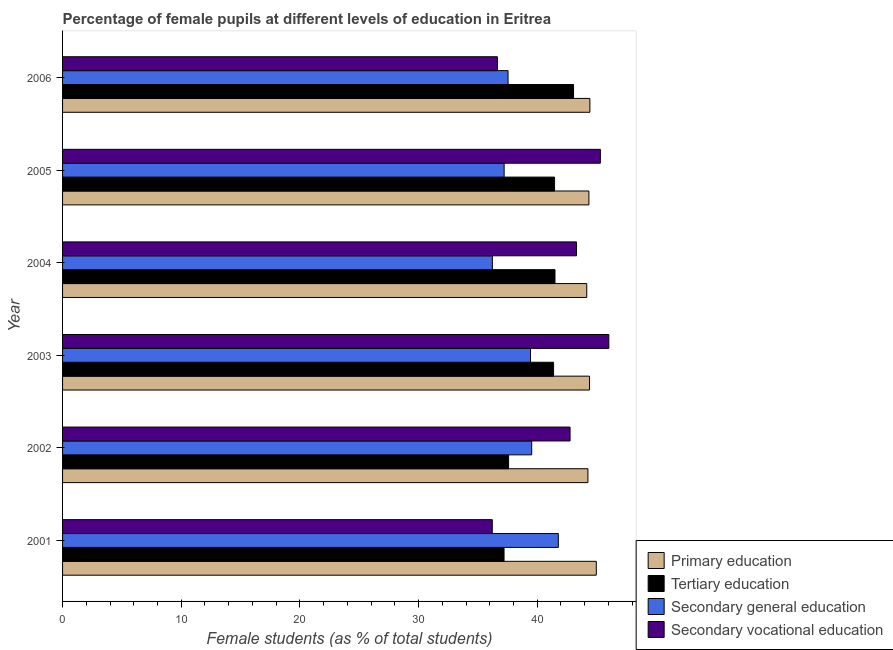How many different coloured bars are there?
Keep it short and to the point. 4. How many groups of bars are there?
Offer a very short reply. 6. Are the number of bars per tick equal to the number of legend labels?
Offer a very short reply. Yes. How many bars are there on the 2nd tick from the top?
Provide a succinct answer. 4. In how many cases, is the number of bars for a given year not equal to the number of legend labels?
Your response must be concise. 0. What is the percentage of female students in tertiary education in 2004?
Your answer should be very brief. 41.5. Across all years, what is the maximum percentage of female students in secondary vocational education?
Keep it short and to the point. 46.03. Across all years, what is the minimum percentage of female students in primary education?
Provide a short and direct response. 44.17. In which year was the percentage of female students in tertiary education maximum?
Give a very brief answer. 2006. In which year was the percentage of female students in primary education minimum?
Provide a succinct answer. 2004. What is the total percentage of female students in secondary vocational education in the graph?
Your answer should be compact. 250.29. What is the difference between the percentage of female students in primary education in 2003 and that in 2005?
Provide a succinct answer. 0.05. What is the difference between the percentage of female students in primary education in 2003 and the percentage of female students in secondary vocational education in 2005?
Provide a succinct answer. -0.91. What is the average percentage of female students in secondary education per year?
Your answer should be compact. 38.62. In the year 2005, what is the difference between the percentage of female students in secondary vocational education and percentage of female students in secondary education?
Offer a very short reply. 8.11. In how many years, is the percentage of female students in tertiary education greater than 34 %?
Keep it short and to the point. 6. What is the ratio of the percentage of female students in secondary education in 2001 to that in 2006?
Your answer should be compact. 1.11. What is the difference between the highest and the second highest percentage of female students in primary education?
Ensure brevity in your answer.  0.54. What is the difference between the highest and the lowest percentage of female students in tertiary education?
Keep it short and to the point. 5.86. In how many years, is the percentage of female students in primary education greater than the average percentage of female students in primary education taken over all years?
Provide a short and direct response. 2. Is it the case that in every year, the sum of the percentage of female students in secondary vocational education and percentage of female students in tertiary education is greater than the sum of percentage of female students in secondary education and percentage of female students in primary education?
Keep it short and to the point. No. What does the 2nd bar from the top in 2006 represents?
Keep it short and to the point. Secondary general education. What does the 3rd bar from the bottom in 2002 represents?
Give a very brief answer. Secondary general education. Is it the case that in every year, the sum of the percentage of female students in primary education and percentage of female students in tertiary education is greater than the percentage of female students in secondary education?
Make the answer very short. Yes. How many bars are there?
Make the answer very short. 24. Are all the bars in the graph horizontal?
Keep it short and to the point. Yes. Does the graph contain grids?
Offer a very short reply. No. Where does the legend appear in the graph?
Your answer should be very brief. Bottom right. How many legend labels are there?
Keep it short and to the point. 4. What is the title of the graph?
Provide a succinct answer. Percentage of female pupils at different levels of education in Eritrea. What is the label or title of the X-axis?
Your answer should be compact. Female students (as % of total students). What is the Female students (as % of total students) in Primary education in 2001?
Your answer should be compact. 44.98. What is the Female students (as % of total students) in Tertiary education in 2001?
Provide a succinct answer. 37.2. What is the Female students (as % of total students) of Secondary general education in 2001?
Offer a terse response. 41.78. What is the Female students (as % of total students) of Secondary vocational education in 2001?
Give a very brief answer. 36.21. What is the Female students (as % of total students) of Primary education in 2002?
Your response must be concise. 44.27. What is the Female students (as % of total students) in Tertiary education in 2002?
Offer a very short reply. 37.59. What is the Female students (as % of total students) in Secondary general education in 2002?
Provide a short and direct response. 39.53. What is the Female students (as % of total students) in Secondary vocational education in 2002?
Offer a very short reply. 42.77. What is the Female students (as % of total students) of Primary education in 2003?
Give a very brief answer. 44.41. What is the Female students (as % of total students) in Tertiary education in 2003?
Provide a succinct answer. 41.38. What is the Female students (as % of total students) in Secondary general education in 2003?
Give a very brief answer. 39.44. What is the Female students (as % of total students) of Secondary vocational education in 2003?
Offer a terse response. 46.03. What is the Female students (as % of total students) in Primary education in 2004?
Your answer should be very brief. 44.17. What is the Female students (as % of total students) in Tertiary education in 2004?
Your response must be concise. 41.5. What is the Female students (as % of total students) in Secondary general education in 2004?
Give a very brief answer. 36.22. What is the Female students (as % of total students) in Secondary vocational education in 2004?
Your response must be concise. 43.31. What is the Female students (as % of total students) of Primary education in 2005?
Provide a succinct answer. 44.36. What is the Female students (as % of total students) in Tertiary education in 2005?
Offer a very short reply. 41.46. What is the Female students (as % of total students) of Secondary general education in 2005?
Your response must be concise. 37.21. What is the Female students (as % of total students) in Secondary vocational education in 2005?
Provide a short and direct response. 45.32. What is the Female students (as % of total students) in Primary education in 2006?
Provide a short and direct response. 44.44. What is the Female students (as % of total students) of Tertiary education in 2006?
Give a very brief answer. 43.06. What is the Female students (as % of total students) of Secondary general education in 2006?
Give a very brief answer. 37.54. What is the Female students (as % of total students) in Secondary vocational education in 2006?
Your response must be concise. 36.65. Across all years, what is the maximum Female students (as % of total students) in Primary education?
Keep it short and to the point. 44.98. Across all years, what is the maximum Female students (as % of total students) of Tertiary education?
Offer a terse response. 43.06. Across all years, what is the maximum Female students (as % of total students) in Secondary general education?
Ensure brevity in your answer.  41.78. Across all years, what is the maximum Female students (as % of total students) of Secondary vocational education?
Make the answer very short. 46.03. Across all years, what is the minimum Female students (as % of total students) in Primary education?
Your response must be concise. 44.17. Across all years, what is the minimum Female students (as % of total students) in Tertiary education?
Provide a short and direct response. 37.2. Across all years, what is the minimum Female students (as % of total students) of Secondary general education?
Offer a terse response. 36.22. Across all years, what is the minimum Female students (as % of total students) in Secondary vocational education?
Your response must be concise. 36.21. What is the total Female students (as % of total students) of Primary education in the graph?
Ensure brevity in your answer.  266.63. What is the total Female students (as % of total students) in Tertiary education in the graph?
Give a very brief answer. 242.19. What is the total Female students (as % of total students) in Secondary general education in the graph?
Give a very brief answer. 231.72. What is the total Female students (as % of total students) of Secondary vocational education in the graph?
Provide a short and direct response. 250.29. What is the difference between the Female students (as % of total students) of Primary education in 2001 and that in 2002?
Your response must be concise. 0.71. What is the difference between the Female students (as % of total students) of Tertiary education in 2001 and that in 2002?
Provide a short and direct response. -0.38. What is the difference between the Female students (as % of total students) of Secondary general education in 2001 and that in 2002?
Keep it short and to the point. 2.25. What is the difference between the Female students (as % of total students) of Secondary vocational education in 2001 and that in 2002?
Keep it short and to the point. -6.55. What is the difference between the Female students (as % of total students) of Primary education in 2001 and that in 2003?
Keep it short and to the point. 0.57. What is the difference between the Female students (as % of total students) of Tertiary education in 2001 and that in 2003?
Ensure brevity in your answer.  -4.17. What is the difference between the Female students (as % of total students) of Secondary general education in 2001 and that in 2003?
Give a very brief answer. 2.34. What is the difference between the Female students (as % of total students) in Secondary vocational education in 2001 and that in 2003?
Keep it short and to the point. -9.82. What is the difference between the Female students (as % of total students) of Primary education in 2001 and that in 2004?
Make the answer very short. 0.8. What is the difference between the Female students (as % of total students) of Tertiary education in 2001 and that in 2004?
Offer a very short reply. -4.29. What is the difference between the Female students (as % of total students) of Secondary general education in 2001 and that in 2004?
Provide a succinct answer. 5.56. What is the difference between the Female students (as % of total students) in Secondary vocational education in 2001 and that in 2004?
Provide a succinct answer. -7.1. What is the difference between the Female students (as % of total students) of Primary education in 2001 and that in 2005?
Make the answer very short. 0.62. What is the difference between the Female students (as % of total students) in Tertiary education in 2001 and that in 2005?
Give a very brief answer. -4.26. What is the difference between the Female students (as % of total students) of Secondary general education in 2001 and that in 2005?
Keep it short and to the point. 4.57. What is the difference between the Female students (as % of total students) of Secondary vocational education in 2001 and that in 2005?
Provide a short and direct response. -9.11. What is the difference between the Female students (as % of total students) in Primary education in 2001 and that in 2006?
Your response must be concise. 0.54. What is the difference between the Female students (as % of total students) of Tertiary education in 2001 and that in 2006?
Provide a short and direct response. -5.86. What is the difference between the Female students (as % of total students) of Secondary general education in 2001 and that in 2006?
Provide a short and direct response. 4.24. What is the difference between the Female students (as % of total students) of Secondary vocational education in 2001 and that in 2006?
Ensure brevity in your answer.  -0.43. What is the difference between the Female students (as % of total students) in Primary education in 2002 and that in 2003?
Give a very brief answer. -0.14. What is the difference between the Female students (as % of total students) in Tertiary education in 2002 and that in 2003?
Give a very brief answer. -3.79. What is the difference between the Female students (as % of total students) of Secondary general education in 2002 and that in 2003?
Give a very brief answer. 0.1. What is the difference between the Female students (as % of total students) of Secondary vocational education in 2002 and that in 2003?
Offer a very short reply. -3.27. What is the difference between the Female students (as % of total students) in Primary education in 2002 and that in 2004?
Give a very brief answer. 0.1. What is the difference between the Female students (as % of total students) in Tertiary education in 2002 and that in 2004?
Offer a very short reply. -3.91. What is the difference between the Female students (as % of total students) of Secondary general education in 2002 and that in 2004?
Give a very brief answer. 3.31. What is the difference between the Female students (as % of total students) of Secondary vocational education in 2002 and that in 2004?
Provide a succinct answer. -0.54. What is the difference between the Female students (as % of total students) in Primary education in 2002 and that in 2005?
Your answer should be compact. -0.09. What is the difference between the Female students (as % of total students) of Tertiary education in 2002 and that in 2005?
Offer a very short reply. -3.87. What is the difference between the Female students (as % of total students) of Secondary general education in 2002 and that in 2005?
Make the answer very short. 2.32. What is the difference between the Female students (as % of total students) in Secondary vocational education in 2002 and that in 2005?
Keep it short and to the point. -2.56. What is the difference between the Female students (as % of total students) in Primary education in 2002 and that in 2006?
Give a very brief answer. -0.17. What is the difference between the Female students (as % of total students) of Tertiary education in 2002 and that in 2006?
Make the answer very short. -5.47. What is the difference between the Female students (as % of total students) in Secondary general education in 2002 and that in 2006?
Your answer should be compact. 1.99. What is the difference between the Female students (as % of total students) of Secondary vocational education in 2002 and that in 2006?
Your answer should be very brief. 6.12. What is the difference between the Female students (as % of total students) in Primary education in 2003 and that in 2004?
Provide a short and direct response. 0.23. What is the difference between the Female students (as % of total students) in Tertiary education in 2003 and that in 2004?
Offer a terse response. -0.12. What is the difference between the Female students (as % of total students) of Secondary general education in 2003 and that in 2004?
Ensure brevity in your answer.  3.21. What is the difference between the Female students (as % of total students) in Secondary vocational education in 2003 and that in 2004?
Keep it short and to the point. 2.72. What is the difference between the Female students (as % of total students) of Primary education in 2003 and that in 2005?
Your answer should be very brief. 0.05. What is the difference between the Female students (as % of total students) of Tertiary education in 2003 and that in 2005?
Your answer should be very brief. -0.08. What is the difference between the Female students (as % of total students) of Secondary general education in 2003 and that in 2005?
Your answer should be very brief. 2.22. What is the difference between the Female students (as % of total students) in Secondary vocational education in 2003 and that in 2005?
Ensure brevity in your answer.  0.71. What is the difference between the Female students (as % of total students) in Primary education in 2003 and that in 2006?
Your response must be concise. -0.03. What is the difference between the Female students (as % of total students) of Tertiary education in 2003 and that in 2006?
Give a very brief answer. -1.68. What is the difference between the Female students (as % of total students) of Secondary general education in 2003 and that in 2006?
Give a very brief answer. 1.89. What is the difference between the Female students (as % of total students) of Secondary vocational education in 2003 and that in 2006?
Give a very brief answer. 9.39. What is the difference between the Female students (as % of total students) in Primary education in 2004 and that in 2005?
Make the answer very short. -0.18. What is the difference between the Female students (as % of total students) in Tertiary education in 2004 and that in 2005?
Your response must be concise. 0.04. What is the difference between the Female students (as % of total students) in Secondary general education in 2004 and that in 2005?
Make the answer very short. -0.99. What is the difference between the Female students (as % of total students) in Secondary vocational education in 2004 and that in 2005?
Give a very brief answer. -2.01. What is the difference between the Female students (as % of total students) of Primary education in 2004 and that in 2006?
Your answer should be very brief. -0.26. What is the difference between the Female students (as % of total students) of Tertiary education in 2004 and that in 2006?
Your answer should be compact. -1.56. What is the difference between the Female students (as % of total students) in Secondary general education in 2004 and that in 2006?
Make the answer very short. -1.32. What is the difference between the Female students (as % of total students) in Secondary vocational education in 2004 and that in 2006?
Your response must be concise. 6.66. What is the difference between the Female students (as % of total students) of Primary education in 2005 and that in 2006?
Provide a short and direct response. -0.08. What is the difference between the Female students (as % of total students) in Tertiary education in 2005 and that in 2006?
Your answer should be compact. -1.6. What is the difference between the Female students (as % of total students) of Secondary general education in 2005 and that in 2006?
Ensure brevity in your answer.  -0.33. What is the difference between the Female students (as % of total students) of Secondary vocational education in 2005 and that in 2006?
Your answer should be compact. 8.68. What is the difference between the Female students (as % of total students) of Primary education in 2001 and the Female students (as % of total students) of Tertiary education in 2002?
Make the answer very short. 7.39. What is the difference between the Female students (as % of total students) in Primary education in 2001 and the Female students (as % of total students) in Secondary general education in 2002?
Offer a very short reply. 5.45. What is the difference between the Female students (as % of total students) of Primary education in 2001 and the Female students (as % of total students) of Secondary vocational education in 2002?
Ensure brevity in your answer.  2.21. What is the difference between the Female students (as % of total students) in Tertiary education in 2001 and the Female students (as % of total students) in Secondary general education in 2002?
Provide a succinct answer. -2.33. What is the difference between the Female students (as % of total students) in Tertiary education in 2001 and the Female students (as % of total students) in Secondary vocational education in 2002?
Your response must be concise. -5.56. What is the difference between the Female students (as % of total students) in Secondary general education in 2001 and the Female students (as % of total students) in Secondary vocational education in 2002?
Keep it short and to the point. -0.99. What is the difference between the Female students (as % of total students) of Primary education in 2001 and the Female students (as % of total students) of Tertiary education in 2003?
Offer a very short reply. 3.6. What is the difference between the Female students (as % of total students) in Primary education in 2001 and the Female students (as % of total students) in Secondary general education in 2003?
Ensure brevity in your answer.  5.54. What is the difference between the Female students (as % of total students) in Primary education in 2001 and the Female students (as % of total students) in Secondary vocational education in 2003?
Your answer should be very brief. -1.06. What is the difference between the Female students (as % of total students) in Tertiary education in 2001 and the Female students (as % of total students) in Secondary general education in 2003?
Your answer should be very brief. -2.23. What is the difference between the Female students (as % of total students) in Tertiary education in 2001 and the Female students (as % of total students) in Secondary vocational education in 2003?
Your response must be concise. -8.83. What is the difference between the Female students (as % of total students) in Secondary general education in 2001 and the Female students (as % of total students) in Secondary vocational education in 2003?
Your answer should be compact. -4.26. What is the difference between the Female students (as % of total students) of Primary education in 2001 and the Female students (as % of total students) of Tertiary education in 2004?
Provide a short and direct response. 3.48. What is the difference between the Female students (as % of total students) in Primary education in 2001 and the Female students (as % of total students) in Secondary general education in 2004?
Ensure brevity in your answer.  8.76. What is the difference between the Female students (as % of total students) of Primary education in 2001 and the Female students (as % of total students) of Secondary vocational education in 2004?
Give a very brief answer. 1.67. What is the difference between the Female students (as % of total students) of Tertiary education in 2001 and the Female students (as % of total students) of Secondary general education in 2004?
Your answer should be very brief. 0.98. What is the difference between the Female students (as % of total students) in Tertiary education in 2001 and the Female students (as % of total students) in Secondary vocational education in 2004?
Make the answer very short. -6.11. What is the difference between the Female students (as % of total students) of Secondary general education in 2001 and the Female students (as % of total students) of Secondary vocational education in 2004?
Offer a terse response. -1.53. What is the difference between the Female students (as % of total students) in Primary education in 2001 and the Female students (as % of total students) in Tertiary education in 2005?
Provide a short and direct response. 3.52. What is the difference between the Female students (as % of total students) of Primary education in 2001 and the Female students (as % of total students) of Secondary general education in 2005?
Offer a terse response. 7.77. What is the difference between the Female students (as % of total students) in Primary education in 2001 and the Female students (as % of total students) in Secondary vocational education in 2005?
Provide a succinct answer. -0.34. What is the difference between the Female students (as % of total students) in Tertiary education in 2001 and the Female students (as % of total students) in Secondary general education in 2005?
Provide a succinct answer. -0.01. What is the difference between the Female students (as % of total students) in Tertiary education in 2001 and the Female students (as % of total students) in Secondary vocational education in 2005?
Offer a very short reply. -8.12. What is the difference between the Female students (as % of total students) in Secondary general education in 2001 and the Female students (as % of total students) in Secondary vocational education in 2005?
Offer a very short reply. -3.54. What is the difference between the Female students (as % of total students) in Primary education in 2001 and the Female students (as % of total students) in Tertiary education in 2006?
Offer a terse response. 1.92. What is the difference between the Female students (as % of total students) in Primary education in 2001 and the Female students (as % of total students) in Secondary general education in 2006?
Keep it short and to the point. 7.44. What is the difference between the Female students (as % of total students) of Primary education in 2001 and the Female students (as % of total students) of Secondary vocational education in 2006?
Ensure brevity in your answer.  8.33. What is the difference between the Female students (as % of total students) of Tertiary education in 2001 and the Female students (as % of total students) of Secondary general education in 2006?
Your answer should be compact. -0.34. What is the difference between the Female students (as % of total students) in Tertiary education in 2001 and the Female students (as % of total students) in Secondary vocational education in 2006?
Keep it short and to the point. 0.56. What is the difference between the Female students (as % of total students) in Secondary general education in 2001 and the Female students (as % of total students) in Secondary vocational education in 2006?
Ensure brevity in your answer.  5.13. What is the difference between the Female students (as % of total students) in Primary education in 2002 and the Female students (as % of total students) in Tertiary education in 2003?
Your answer should be very brief. 2.89. What is the difference between the Female students (as % of total students) in Primary education in 2002 and the Female students (as % of total students) in Secondary general education in 2003?
Offer a terse response. 4.84. What is the difference between the Female students (as % of total students) in Primary education in 2002 and the Female students (as % of total students) in Secondary vocational education in 2003?
Your answer should be very brief. -1.76. What is the difference between the Female students (as % of total students) of Tertiary education in 2002 and the Female students (as % of total students) of Secondary general education in 2003?
Your answer should be very brief. -1.85. What is the difference between the Female students (as % of total students) of Tertiary education in 2002 and the Female students (as % of total students) of Secondary vocational education in 2003?
Your response must be concise. -8.45. What is the difference between the Female students (as % of total students) in Secondary general education in 2002 and the Female students (as % of total students) in Secondary vocational education in 2003?
Your answer should be very brief. -6.5. What is the difference between the Female students (as % of total students) in Primary education in 2002 and the Female students (as % of total students) in Tertiary education in 2004?
Provide a succinct answer. 2.77. What is the difference between the Female students (as % of total students) of Primary education in 2002 and the Female students (as % of total students) of Secondary general education in 2004?
Offer a very short reply. 8.05. What is the difference between the Female students (as % of total students) of Primary education in 2002 and the Female students (as % of total students) of Secondary vocational education in 2004?
Provide a short and direct response. 0.96. What is the difference between the Female students (as % of total students) of Tertiary education in 2002 and the Female students (as % of total students) of Secondary general education in 2004?
Ensure brevity in your answer.  1.37. What is the difference between the Female students (as % of total students) of Tertiary education in 2002 and the Female students (as % of total students) of Secondary vocational education in 2004?
Your response must be concise. -5.72. What is the difference between the Female students (as % of total students) of Secondary general education in 2002 and the Female students (as % of total students) of Secondary vocational education in 2004?
Offer a terse response. -3.78. What is the difference between the Female students (as % of total students) in Primary education in 2002 and the Female students (as % of total students) in Tertiary education in 2005?
Offer a terse response. 2.81. What is the difference between the Female students (as % of total students) of Primary education in 2002 and the Female students (as % of total students) of Secondary general education in 2005?
Ensure brevity in your answer.  7.06. What is the difference between the Female students (as % of total students) in Primary education in 2002 and the Female students (as % of total students) in Secondary vocational education in 2005?
Ensure brevity in your answer.  -1.05. What is the difference between the Female students (as % of total students) of Tertiary education in 2002 and the Female students (as % of total students) of Secondary general education in 2005?
Offer a very short reply. 0.38. What is the difference between the Female students (as % of total students) in Tertiary education in 2002 and the Female students (as % of total students) in Secondary vocational education in 2005?
Your answer should be compact. -7.73. What is the difference between the Female students (as % of total students) of Secondary general education in 2002 and the Female students (as % of total students) of Secondary vocational education in 2005?
Offer a terse response. -5.79. What is the difference between the Female students (as % of total students) of Primary education in 2002 and the Female students (as % of total students) of Tertiary education in 2006?
Keep it short and to the point. 1.21. What is the difference between the Female students (as % of total students) of Primary education in 2002 and the Female students (as % of total students) of Secondary general education in 2006?
Ensure brevity in your answer.  6.73. What is the difference between the Female students (as % of total students) in Primary education in 2002 and the Female students (as % of total students) in Secondary vocational education in 2006?
Provide a succinct answer. 7.62. What is the difference between the Female students (as % of total students) in Tertiary education in 2002 and the Female students (as % of total students) in Secondary general education in 2006?
Provide a short and direct response. 0.05. What is the difference between the Female students (as % of total students) in Tertiary education in 2002 and the Female students (as % of total students) in Secondary vocational education in 2006?
Offer a terse response. 0.94. What is the difference between the Female students (as % of total students) in Secondary general education in 2002 and the Female students (as % of total students) in Secondary vocational education in 2006?
Offer a terse response. 2.89. What is the difference between the Female students (as % of total students) in Primary education in 2003 and the Female students (as % of total students) in Tertiary education in 2004?
Ensure brevity in your answer.  2.91. What is the difference between the Female students (as % of total students) of Primary education in 2003 and the Female students (as % of total students) of Secondary general education in 2004?
Offer a terse response. 8.19. What is the difference between the Female students (as % of total students) in Primary education in 2003 and the Female students (as % of total students) in Secondary vocational education in 2004?
Give a very brief answer. 1.1. What is the difference between the Female students (as % of total students) of Tertiary education in 2003 and the Female students (as % of total students) of Secondary general education in 2004?
Keep it short and to the point. 5.16. What is the difference between the Female students (as % of total students) in Tertiary education in 2003 and the Female students (as % of total students) in Secondary vocational education in 2004?
Your response must be concise. -1.93. What is the difference between the Female students (as % of total students) of Secondary general education in 2003 and the Female students (as % of total students) of Secondary vocational education in 2004?
Give a very brief answer. -3.88. What is the difference between the Female students (as % of total students) in Primary education in 2003 and the Female students (as % of total students) in Tertiary education in 2005?
Your response must be concise. 2.95. What is the difference between the Female students (as % of total students) of Primary education in 2003 and the Female students (as % of total students) of Secondary general education in 2005?
Your answer should be very brief. 7.2. What is the difference between the Female students (as % of total students) in Primary education in 2003 and the Female students (as % of total students) in Secondary vocational education in 2005?
Your answer should be very brief. -0.91. What is the difference between the Female students (as % of total students) of Tertiary education in 2003 and the Female students (as % of total students) of Secondary general education in 2005?
Give a very brief answer. 4.17. What is the difference between the Female students (as % of total students) of Tertiary education in 2003 and the Female students (as % of total students) of Secondary vocational education in 2005?
Make the answer very short. -3.94. What is the difference between the Female students (as % of total students) in Secondary general education in 2003 and the Female students (as % of total students) in Secondary vocational education in 2005?
Offer a very short reply. -5.89. What is the difference between the Female students (as % of total students) of Primary education in 2003 and the Female students (as % of total students) of Tertiary education in 2006?
Your answer should be compact. 1.35. What is the difference between the Female students (as % of total students) in Primary education in 2003 and the Female students (as % of total students) in Secondary general education in 2006?
Provide a succinct answer. 6.87. What is the difference between the Female students (as % of total students) of Primary education in 2003 and the Female students (as % of total students) of Secondary vocational education in 2006?
Ensure brevity in your answer.  7.76. What is the difference between the Female students (as % of total students) in Tertiary education in 2003 and the Female students (as % of total students) in Secondary general education in 2006?
Your response must be concise. 3.84. What is the difference between the Female students (as % of total students) of Tertiary education in 2003 and the Female students (as % of total students) of Secondary vocational education in 2006?
Provide a short and direct response. 4.73. What is the difference between the Female students (as % of total students) of Secondary general education in 2003 and the Female students (as % of total students) of Secondary vocational education in 2006?
Your answer should be compact. 2.79. What is the difference between the Female students (as % of total students) in Primary education in 2004 and the Female students (as % of total students) in Tertiary education in 2005?
Your answer should be compact. 2.71. What is the difference between the Female students (as % of total students) of Primary education in 2004 and the Female students (as % of total students) of Secondary general education in 2005?
Ensure brevity in your answer.  6.96. What is the difference between the Female students (as % of total students) in Primary education in 2004 and the Female students (as % of total students) in Secondary vocational education in 2005?
Make the answer very short. -1.15. What is the difference between the Female students (as % of total students) in Tertiary education in 2004 and the Female students (as % of total students) in Secondary general education in 2005?
Keep it short and to the point. 4.28. What is the difference between the Female students (as % of total students) of Tertiary education in 2004 and the Female students (as % of total students) of Secondary vocational education in 2005?
Offer a terse response. -3.82. What is the difference between the Female students (as % of total students) in Secondary general education in 2004 and the Female students (as % of total students) in Secondary vocational education in 2005?
Make the answer very short. -9.1. What is the difference between the Female students (as % of total students) of Primary education in 2004 and the Female students (as % of total students) of Tertiary education in 2006?
Give a very brief answer. 1.11. What is the difference between the Female students (as % of total students) of Primary education in 2004 and the Female students (as % of total students) of Secondary general education in 2006?
Ensure brevity in your answer.  6.63. What is the difference between the Female students (as % of total students) of Primary education in 2004 and the Female students (as % of total students) of Secondary vocational education in 2006?
Provide a succinct answer. 7.53. What is the difference between the Female students (as % of total students) of Tertiary education in 2004 and the Female students (as % of total students) of Secondary general education in 2006?
Offer a very short reply. 3.96. What is the difference between the Female students (as % of total students) of Tertiary education in 2004 and the Female students (as % of total students) of Secondary vocational education in 2006?
Your answer should be very brief. 4.85. What is the difference between the Female students (as % of total students) of Secondary general education in 2004 and the Female students (as % of total students) of Secondary vocational education in 2006?
Your response must be concise. -0.43. What is the difference between the Female students (as % of total students) in Primary education in 2005 and the Female students (as % of total students) in Tertiary education in 2006?
Provide a succinct answer. 1.3. What is the difference between the Female students (as % of total students) in Primary education in 2005 and the Female students (as % of total students) in Secondary general education in 2006?
Provide a succinct answer. 6.81. What is the difference between the Female students (as % of total students) in Primary education in 2005 and the Female students (as % of total students) in Secondary vocational education in 2006?
Your answer should be very brief. 7.71. What is the difference between the Female students (as % of total students) in Tertiary education in 2005 and the Female students (as % of total students) in Secondary general education in 2006?
Provide a succinct answer. 3.92. What is the difference between the Female students (as % of total students) in Tertiary education in 2005 and the Female students (as % of total students) in Secondary vocational education in 2006?
Offer a terse response. 4.82. What is the difference between the Female students (as % of total students) of Secondary general education in 2005 and the Female students (as % of total students) of Secondary vocational education in 2006?
Make the answer very short. 0.57. What is the average Female students (as % of total students) in Primary education per year?
Provide a short and direct response. 44.44. What is the average Female students (as % of total students) of Tertiary education per year?
Keep it short and to the point. 40.37. What is the average Female students (as % of total students) in Secondary general education per year?
Keep it short and to the point. 38.62. What is the average Female students (as % of total students) in Secondary vocational education per year?
Give a very brief answer. 41.72. In the year 2001, what is the difference between the Female students (as % of total students) in Primary education and Female students (as % of total students) in Tertiary education?
Your answer should be compact. 7.77. In the year 2001, what is the difference between the Female students (as % of total students) of Primary education and Female students (as % of total students) of Secondary general education?
Your answer should be very brief. 3.2. In the year 2001, what is the difference between the Female students (as % of total students) of Primary education and Female students (as % of total students) of Secondary vocational education?
Provide a succinct answer. 8.77. In the year 2001, what is the difference between the Female students (as % of total students) of Tertiary education and Female students (as % of total students) of Secondary general education?
Your answer should be very brief. -4.58. In the year 2001, what is the difference between the Female students (as % of total students) of Tertiary education and Female students (as % of total students) of Secondary vocational education?
Ensure brevity in your answer.  0.99. In the year 2001, what is the difference between the Female students (as % of total students) in Secondary general education and Female students (as % of total students) in Secondary vocational education?
Make the answer very short. 5.57. In the year 2002, what is the difference between the Female students (as % of total students) of Primary education and Female students (as % of total students) of Tertiary education?
Provide a short and direct response. 6.68. In the year 2002, what is the difference between the Female students (as % of total students) of Primary education and Female students (as % of total students) of Secondary general education?
Ensure brevity in your answer.  4.74. In the year 2002, what is the difference between the Female students (as % of total students) of Primary education and Female students (as % of total students) of Secondary vocational education?
Offer a very short reply. 1.5. In the year 2002, what is the difference between the Female students (as % of total students) in Tertiary education and Female students (as % of total students) in Secondary general education?
Make the answer very short. -1.94. In the year 2002, what is the difference between the Female students (as % of total students) of Tertiary education and Female students (as % of total students) of Secondary vocational education?
Your answer should be very brief. -5.18. In the year 2002, what is the difference between the Female students (as % of total students) in Secondary general education and Female students (as % of total students) in Secondary vocational education?
Provide a succinct answer. -3.23. In the year 2003, what is the difference between the Female students (as % of total students) of Primary education and Female students (as % of total students) of Tertiary education?
Your answer should be compact. 3.03. In the year 2003, what is the difference between the Female students (as % of total students) in Primary education and Female students (as % of total students) in Secondary general education?
Keep it short and to the point. 4.97. In the year 2003, what is the difference between the Female students (as % of total students) of Primary education and Female students (as % of total students) of Secondary vocational education?
Provide a succinct answer. -1.63. In the year 2003, what is the difference between the Female students (as % of total students) in Tertiary education and Female students (as % of total students) in Secondary general education?
Make the answer very short. 1.94. In the year 2003, what is the difference between the Female students (as % of total students) of Tertiary education and Female students (as % of total students) of Secondary vocational education?
Provide a short and direct response. -4.66. In the year 2003, what is the difference between the Female students (as % of total students) in Secondary general education and Female students (as % of total students) in Secondary vocational education?
Provide a succinct answer. -6.6. In the year 2004, what is the difference between the Female students (as % of total students) in Primary education and Female students (as % of total students) in Tertiary education?
Keep it short and to the point. 2.68. In the year 2004, what is the difference between the Female students (as % of total students) in Primary education and Female students (as % of total students) in Secondary general education?
Your answer should be very brief. 7.95. In the year 2004, what is the difference between the Female students (as % of total students) of Primary education and Female students (as % of total students) of Secondary vocational education?
Make the answer very short. 0.86. In the year 2004, what is the difference between the Female students (as % of total students) in Tertiary education and Female students (as % of total students) in Secondary general education?
Offer a very short reply. 5.28. In the year 2004, what is the difference between the Female students (as % of total students) in Tertiary education and Female students (as % of total students) in Secondary vocational education?
Keep it short and to the point. -1.81. In the year 2004, what is the difference between the Female students (as % of total students) in Secondary general education and Female students (as % of total students) in Secondary vocational education?
Provide a succinct answer. -7.09. In the year 2005, what is the difference between the Female students (as % of total students) of Primary education and Female students (as % of total students) of Tertiary education?
Your answer should be very brief. 2.89. In the year 2005, what is the difference between the Female students (as % of total students) of Primary education and Female students (as % of total students) of Secondary general education?
Ensure brevity in your answer.  7.14. In the year 2005, what is the difference between the Female students (as % of total students) in Primary education and Female students (as % of total students) in Secondary vocational education?
Ensure brevity in your answer.  -0.97. In the year 2005, what is the difference between the Female students (as % of total students) in Tertiary education and Female students (as % of total students) in Secondary general education?
Offer a terse response. 4.25. In the year 2005, what is the difference between the Female students (as % of total students) of Tertiary education and Female students (as % of total students) of Secondary vocational education?
Your response must be concise. -3.86. In the year 2005, what is the difference between the Female students (as % of total students) in Secondary general education and Female students (as % of total students) in Secondary vocational education?
Give a very brief answer. -8.11. In the year 2006, what is the difference between the Female students (as % of total students) of Primary education and Female students (as % of total students) of Tertiary education?
Ensure brevity in your answer.  1.38. In the year 2006, what is the difference between the Female students (as % of total students) in Primary education and Female students (as % of total students) in Secondary general education?
Provide a short and direct response. 6.9. In the year 2006, what is the difference between the Female students (as % of total students) in Primary education and Female students (as % of total students) in Secondary vocational education?
Keep it short and to the point. 7.79. In the year 2006, what is the difference between the Female students (as % of total students) of Tertiary education and Female students (as % of total students) of Secondary general education?
Your response must be concise. 5.52. In the year 2006, what is the difference between the Female students (as % of total students) in Tertiary education and Female students (as % of total students) in Secondary vocational education?
Offer a terse response. 6.41. In the year 2006, what is the difference between the Female students (as % of total students) in Secondary general education and Female students (as % of total students) in Secondary vocational education?
Provide a succinct answer. 0.89. What is the ratio of the Female students (as % of total students) in Primary education in 2001 to that in 2002?
Offer a terse response. 1.02. What is the ratio of the Female students (as % of total students) of Tertiary education in 2001 to that in 2002?
Your answer should be very brief. 0.99. What is the ratio of the Female students (as % of total students) of Secondary general education in 2001 to that in 2002?
Keep it short and to the point. 1.06. What is the ratio of the Female students (as % of total students) of Secondary vocational education in 2001 to that in 2002?
Give a very brief answer. 0.85. What is the ratio of the Female students (as % of total students) of Primary education in 2001 to that in 2003?
Offer a terse response. 1.01. What is the ratio of the Female students (as % of total students) of Tertiary education in 2001 to that in 2003?
Offer a very short reply. 0.9. What is the ratio of the Female students (as % of total students) of Secondary general education in 2001 to that in 2003?
Give a very brief answer. 1.06. What is the ratio of the Female students (as % of total students) in Secondary vocational education in 2001 to that in 2003?
Give a very brief answer. 0.79. What is the ratio of the Female students (as % of total students) in Primary education in 2001 to that in 2004?
Your response must be concise. 1.02. What is the ratio of the Female students (as % of total students) of Tertiary education in 2001 to that in 2004?
Your response must be concise. 0.9. What is the ratio of the Female students (as % of total students) in Secondary general education in 2001 to that in 2004?
Your answer should be compact. 1.15. What is the ratio of the Female students (as % of total students) in Secondary vocational education in 2001 to that in 2004?
Give a very brief answer. 0.84. What is the ratio of the Female students (as % of total students) of Tertiary education in 2001 to that in 2005?
Offer a terse response. 0.9. What is the ratio of the Female students (as % of total students) in Secondary general education in 2001 to that in 2005?
Provide a succinct answer. 1.12. What is the ratio of the Female students (as % of total students) of Secondary vocational education in 2001 to that in 2005?
Your answer should be compact. 0.8. What is the ratio of the Female students (as % of total students) of Primary education in 2001 to that in 2006?
Provide a succinct answer. 1.01. What is the ratio of the Female students (as % of total students) of Tertiary education in 2001 to that in 2006?
Keep it short and to the point. 0.86. What is the ratio of the Female students (as % of total students) in Secondary general education in 2001 to that in 2006?
Provide a succinct answer. 1.11. What is the ratio of the Female students (as % of total students) in Secondary vocational education in 2001 to that in 2006?
Provide a short and direct response. 0.99. What is the ratio of the Female students (as % of total students) of Tertiary education in 2002 to that in 2003?
Your response must be concise. 0.91. What is the ratio of the Female students (as % of total students) of Secondary vocational education in 2002 to that in 2003?
Offer a very short reply. 0.93. What is the ratio of the Female students (as % of total students) of Tertiary education in 2002 to that in 2004?
Provide a short and direct response. 0.91. What is the ratio of the Female students (as % of total students) in Secondary general education in 2002 to that in 2004?
Keep it short and to the point. 1.09. What is the ratio of the Female students (as % of total students) of Secondary vocational education in 2002 to that in 2004?
Give a very brief answer. 0.99. What is the ratio of the Female students (as % of total students) in Primary education in 2002 to that in 2005?
Keep it short and to the point. 1. What is the ratio of the Female students (as % of total students) of Tertiary education in 2002 to that in 2005?
Offer a very short reply. 0.91. What is the ratio of the Female students (as % of total students) in Secondary general education in 2002 to that in 2005?
Your response must be concise. 1.06. What is the ratio of the Female students (as % of total students) of Secondary vocational education in 2002 to that in 2005?
Your answer should be very brief. 0.94. What is the ratio of the Female students (as % of total students) of Tertiary education in 2002 to that in 2006?
Offer a terse response. 0.87. What is the ratio of the Female students (as % of total students) in Secondary general education in 2002 to that in 2006?
Provide a short and direct response. 1.05. What is the ratio of the Female students (as % of total students) of Secondary vocational education in 2002 to that in 2006?
Your answer should be compact. 1.17. What is the ratio of the Female students (as % of total students) of Primary education in 2003 to that in 2004?
Your answer should be very brief. 1.01. What is the ratio of the Female students (as % of total students) of Tertiary education in 2003 to that in 2004?
Your answer should be very brief. 1. What is the ratio of the Female students (as % of total students) in Secondary general education in 2003 to that in 2004?
Your answer should be compact. 1.09. What is the ratio of the Female students (as % of total students) of Secondary vocational education in 2003 to that in 2004?
Provide a succinct answer. 1.06. What is the ratio of the Female students (as % of total students) of Primary education in 2003 to that in 2005?
Offer a very short reply. 1. What is the ratio of the Female students (as % of total students) in Tertiary education in 2003 to that in 2005?
Ensure brevity in your answer.  1. What is the ratio of the Female students (as % of total students) of Secondary general education in 2003 to that in 2005?
Your answer should be very brief. 1.06. What is the ratio of the Female students (as % of total students) of Secondary vocational education in 2003 to that in 2005?
Your response must be concise. 1.02. What is the ratio of the Female students (as % of total students) of Tertiary education in 2003 to that in 2006?
Ensure brevity in your answer.  0.96. What is the ratio of the Female students (as % of total students) of Secondary general education in 2003 to that in 2006?
Provide a succinct answer. 1.05. What is the ratio of the Female students (as % of total students) in Secondary vocational education in 2003 to that in 2006?
Ensure brevity in your answer.  1.26. What is the ratio of the Female students (as % of total students) of Secondary general education in 2004 to that in 2005?
Offer a very short reply. 0.97. What is the ratio of the Female students (as % of total students) of Secondary vocational education in 2004 to that in 2005?
Provide a short and direct response. 0.96. What is the ratio of the Female students (as % of total students) in Tertiary education in 2004 to that in 2006?
Your response must be concise. 0.96. What is the ratio of the Female students (as % of total students) of Secondary general education in 2004 to that in 2006?
Keep it short and to the point. 0.96. What is the ratio of the Female students (as % of total students) in Secondary vocational education in 2004 to that in 2006?
Give a very brief answer. 1.18. What is the ratio of the Female students (as % of total students) in Tertiary education in 2005 to that in 2006?
Give a very brief answer. 0.96. What is the ratio of the Female students (as % of total students) of Secondary general education in 2005 to that in 2006?
Provide a short and direct response. 0.99. What is the ratio of the Female students (as % of total students) in Secondary vocational education in 2005 to that in 2006?
Offer a terse response. 1.24. What is the difference between the highest and the second highest Female students (as % of total students) in Primary education?
Make the answer very short. 0.54. What is the difference between the highest and the second highest Female students (as % of total students) of Tertiary education?
Keep it short and to the point. 1.56. What is the difference between the highest and the second highest Female students (as % of total students) of Secondary general education?
Ensure brevity in your answer.  2.25. What is the difference between the highest and the second highest Female students (as % of total students) of Secondary vocational education?
Keep it short and to the point. 0.71. What is the difference between the highest and the lowest Female students (as % of total students) of Primary education?
Make the answer very short. 0.8. What is the difference between the highest and the lowest Female students (as % of total students) of Tertiary education?
Your answer should be compact. 5.86. What is the difference between the highest and the lowest Female students (as % of total students) in Secondary general education?
Keep it short and to the point. 5.56. What is the difference between the highest and the lowest Female students (as % of total students) in Secondary vocational education?
Ensure brevity in your answer.  9.82. 